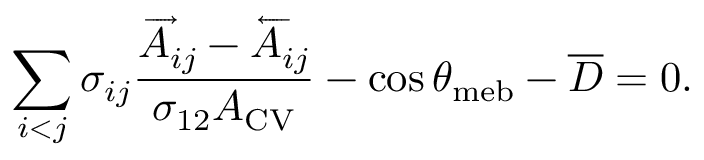<formula> <loc_0><loc_0><loc_500><loc_500>\sum _ { i < j } \sigma _ { i j } \frac { \overrightarrow { A } _ { i j } - \overleftarrow { A } _ { i j } } { \sigma _ { 1 2 } A _ { C V } } - \cos \theta _ { m e b } - \overline { D } = 0 .</formula> 